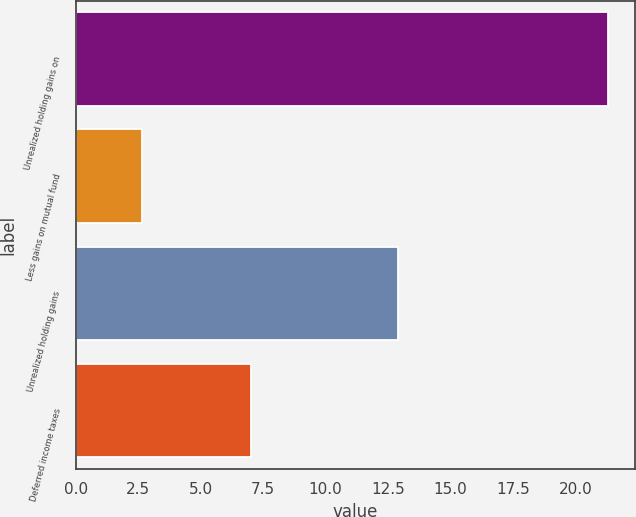Convert chart. <chart><loc_0><loc_0><loc_500><loc_500><bar_chart><fcel>Unrealized holding gains on<fcel>Less gains on mutual fund<fcel>Unrealized holding gains<fcel>Deferred income taxes<nl><fcel>21.3<fcel>2.67<fcel>12.9<fcel>7<nl></chart> 